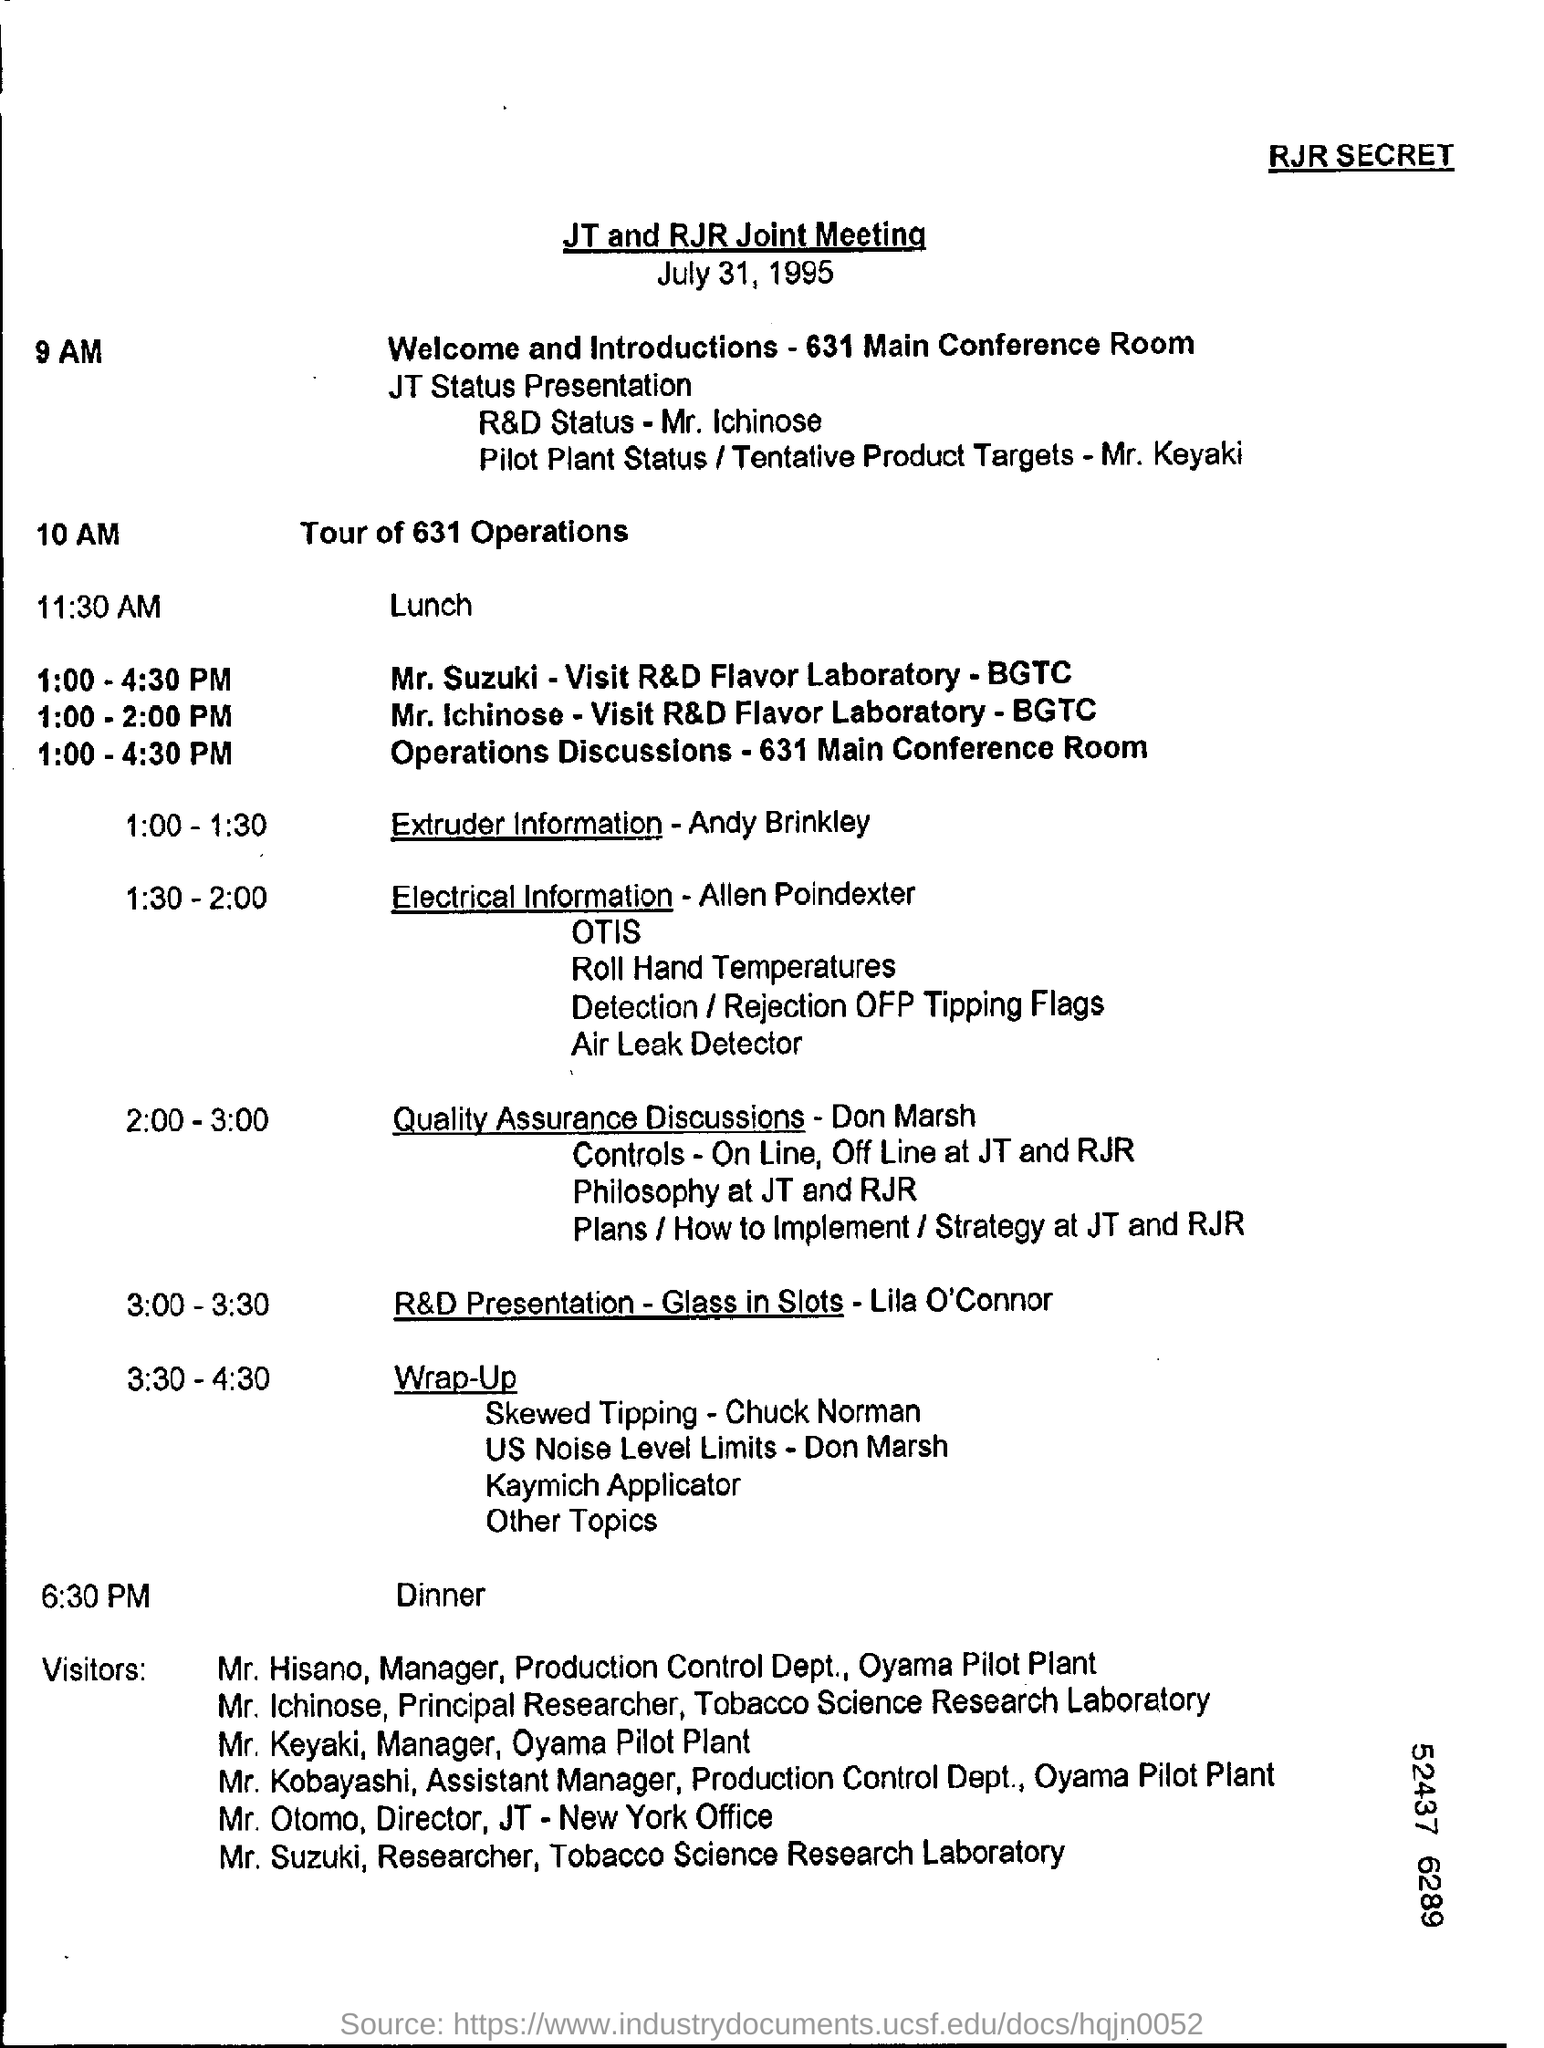Indicate a few pertinent items in this graphic. At 10 am, there will be a tour of 631 Operations. At 1:00 - 2:00 PM, Mr. Ichinose is visiting the R&D Flavor Laboratory of BGTC. The dinner is scheduled for 6:30 PM. 